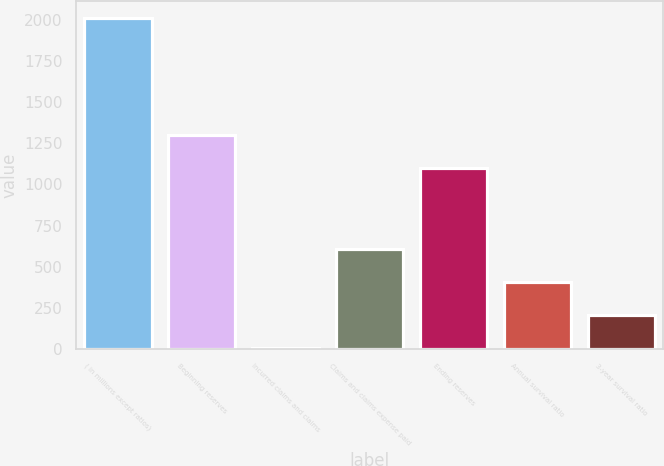<chart> <loc_0><loc_0><loc_500><loc_500><bar_chart><fcel>( in millions except ratios)<fcel>Beginning reserves<fcel>Incurred claims and claims<fcel>Claims and claims expense paid<fcel>Ending reserves<fcel>Annual survival ratio<fcel>3-year survival ratio<nl><fcel>2010<fcel>1300.5<fcel>5<fcel>606.5<fcel>1100<fcel>406<fcel>205.5<nl></chart> 